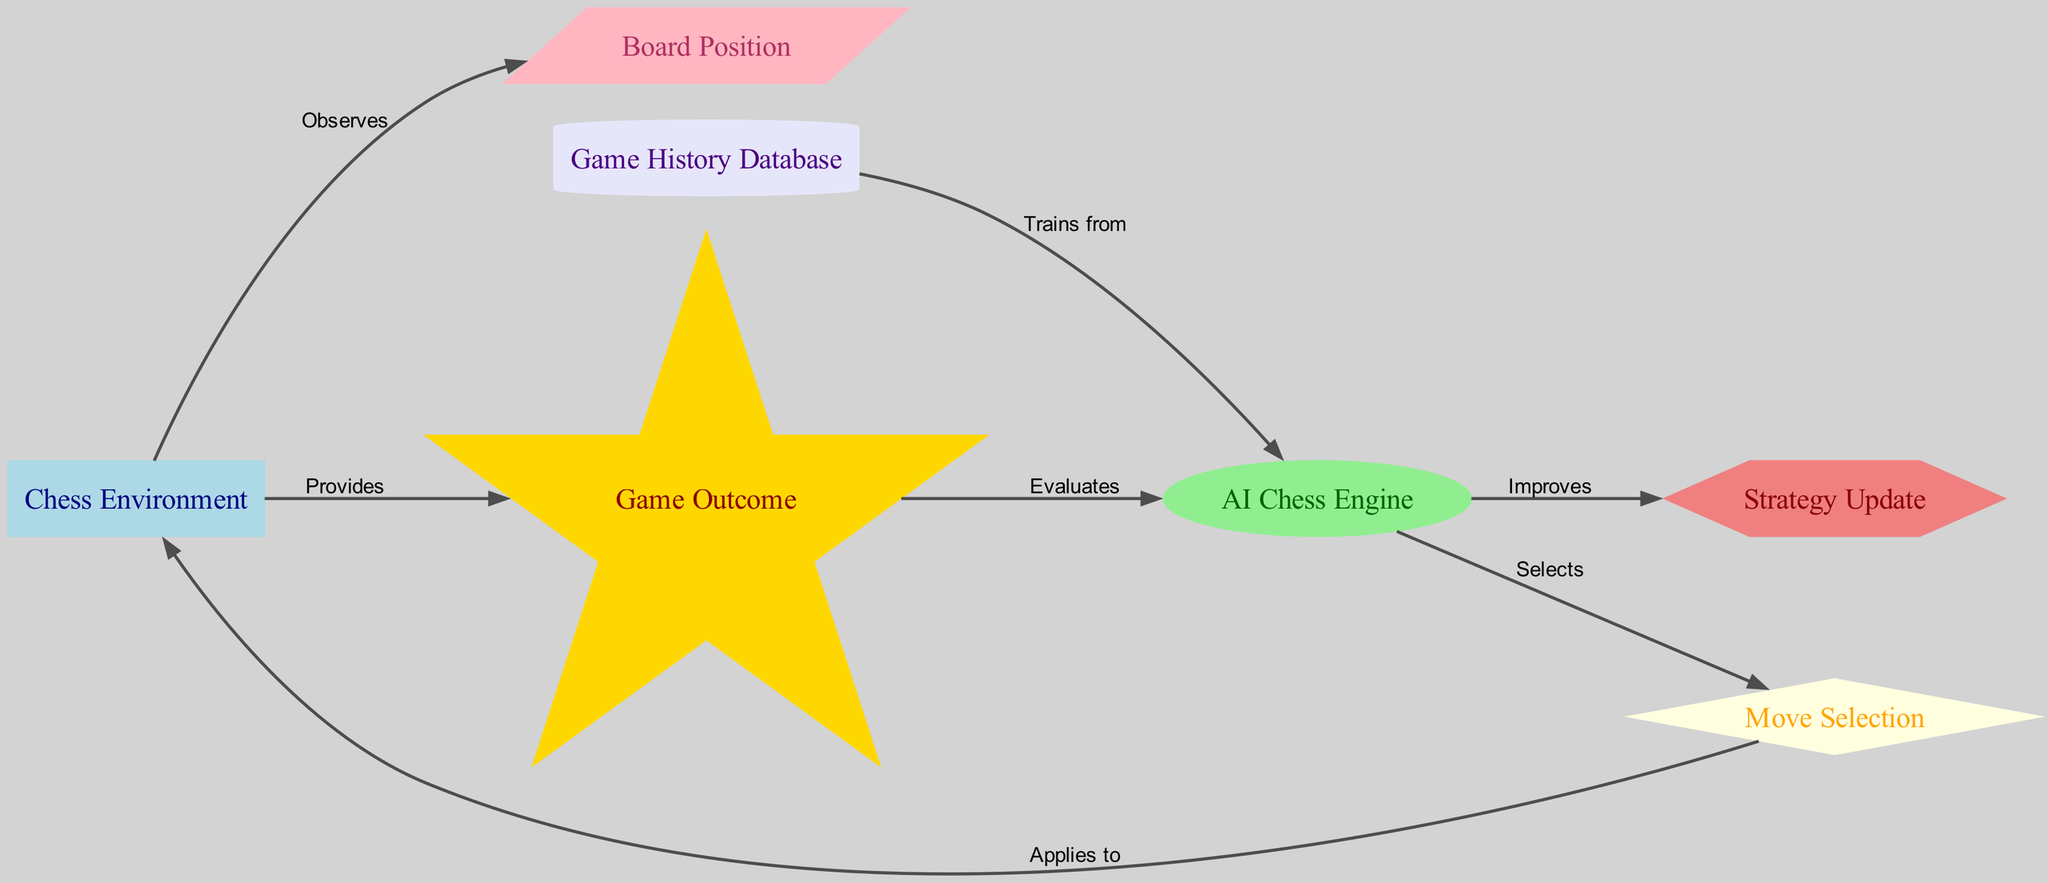What is the label of the node representing the AI's strategy update? The node representing the AI's strategy update is labeled as "Strategy Update". This can be identified by viewing the nodes listed in the diagram, where each node carries a specific label.
Answer: Strategy Update How many nodes are present in the diagram? To find the total number of nodes, we count each unique node listed in the diagram’s nodes section. There are seven nodes total: Chess Environment, AI Chess Engine, Move Selection, Board Position, Game Outcome, Strategy Update, and Game History Database.
Answer: 7 What action does the AI Chess Engine select? The AI Chess Engine selects the action labeled "Move Selection". This is indicated by the directed edge going from the AI Chess Engine to the Move Selection node.
Answer: Move Selection What provides the game outcome to the AI? The game outcome is provided by the "Chess Environment". This is shown by the directed edge from the Chess Environment to the Game Outcome node, indicating the flow of information.
Answer: Chess Environment Which node uses the game history database for training? The node that uses the game history database for training is the "AI Chess Engine". The diagram illustrates this relationship via a directed edge from the Game History Database node to the AI Chess Engine node.
Answer: AI Chess Engine What type of feedback does the 'Reward' node evaluate? The 'Reward' node evaluates the feedback based on the "Game Outcome". This can be observed from the directed edge connecting the Game Outcome to the Reward node, indicating that the outcomes influence the evaluations made by the Reward.
Answer: Game Outcome Which node has a diamond shape in the diagram? The node that has a diamond shape in the diagram is the "Move Selection". The shape of nodes is part of their visual representation in the diagram, clearly shown as a diamond for the Move Selection node.
Answer: Move Selection What action is applied to the chess environment after the AI selects a move? After the AI selects a move, the action that is applied to the chess environment is represented by the "Move Selection". This relationship is depicted in the diagram with a directed edge from the Move Selection node to the Chess Environment node.
Answer: Move Selection 